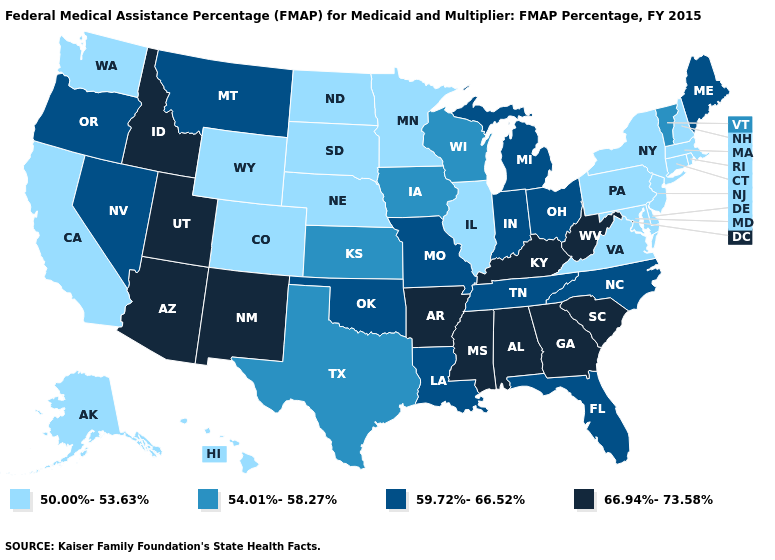What is the highest value in the USA?
Give a very brief answer. 66.94%-73.58%. Which states hav the highest value in the Northeast?
Quick response, please. Maine. Name the states that have a value in the range 59.72%-66.52%?
Short answer required. Florida, Indiana, Louisiana, Maine, Michigan, Missouri, Montana, Nevada, North Carolina, Ohio, Oklahoma, Oregon, Tennessee. Among the states that border North Carolina , does South Carolina have the highest value?
Quick response, please. Yes. Does Alaska have the lowest value in the USA?
Answer briefly. Yes. What is the value of Utah?
Keep it brief. 66.94%-73.58%. Name the states that have a value in the range 54.01%-58.27%?
Concise answer only. Iowa, Kansas, Texas, Vermont, Wisconsin. What is the highest value in the USA?
Write a very short answer. 66.94%-73.58%. Does Massachusetts have a higher value than Mississippi?
Be succinct. No. What is the value of North Dakota?
Short answer required. 50.00%-53.63%. Which states have the highest value in the USA?
Be succinct. Alabama, Arizona, Arkansas, Georgia, Idaho, Kentucky, Mississippi, New Mexico, South Carolina, Utah, West Virginia. What is the highest value in the South ?
Write a very short answer. 66.94%-73.58%. Among the states that border Utah , does New Mexico have the highest value?
Keep it brief. Yes. Which states have the lowest value in the USA?
Keep it brief. Alaska, California, Colorado, Connecticut, Delaware, Hawaii, Illinois, Maryland, Massachusetts, Minnesota, Nebraska, New Hampshire, New Jersey, New York, North Dakota, Pennsylvania, Rhode Island, South Dakota, Virginia, Washington, Wyoming. 